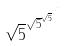<formula> <loc_0><loc_0><loc_500><loc_500>\sqrt { 5 } ^ { \sqrt { 5 } ^ { \sqrt { 5 } ^ { \cdot ^ { \cdot ^ { \cdot } } } } }</formula> 